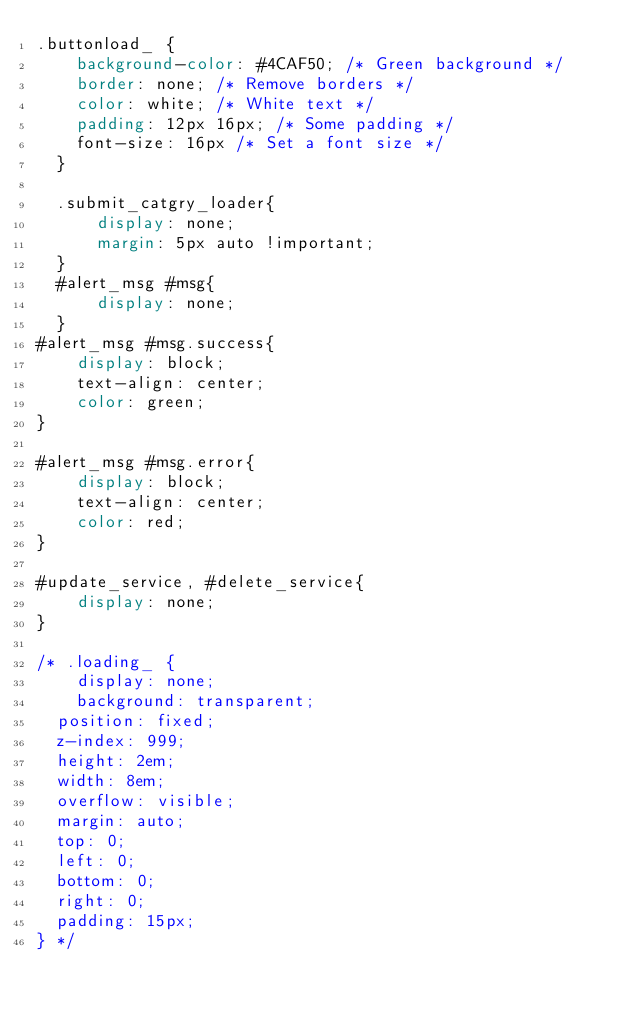<code> <loc_0><loc_0><loc_500><loc_500><_CSS_>.buttonload_ {
    background-color: #4CAF50; /* Green background */
    border: none; /* Remove borders */
    color: white; /* White text */
    padding: 12px 16px; /* Some padding */
    font-size: 16px /* Set a font size */
  }

  .submit_catgry_loader{
      display: none;
      margin: 5px auto !important;
  }
  #alert_msg #msg{
      display: none;
  }
#alert_msg #msg.success{
    display: block;
    text-align: center;
    color: green;
}

#alert_msg #msg.error{
    display: block;
    text-align: center;
    color: red;
}

#update_service, #delete_service{
    display: none;
}

/* .loading_ {
    display: none;
    background: transparent;
	position: fixed;
	z-index: 999;
	height: 2em;
	width: 8em;
	overflow: visible;
	margin: auto;
	top: 0;
	left: 0;
	bottom: 0;
	right: 0;
	padding: 15px;
} */
  </code> 